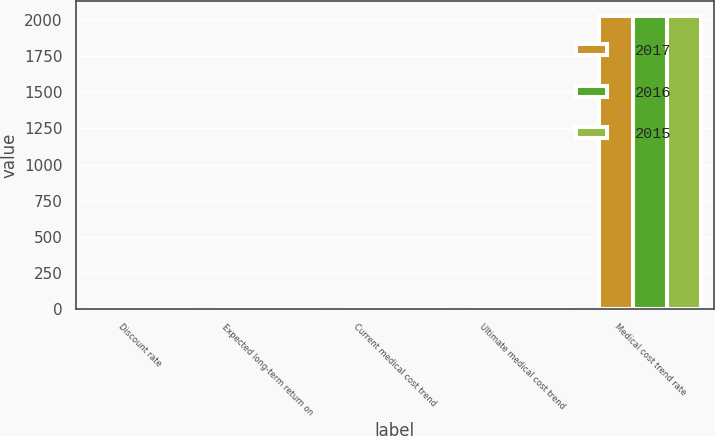Convert chart to OTSL. <chart><loc_0><loc_0><loc_500><loc_500><stacked_bar_chart><ecel><fcel>Discount rate<fcel>Expected long-term return on<fcel>Current medical cost trend<fcel>Ultimate medical cost trend<fcel>Medical cost trend rate<nl><fcel>2017<fcel>3.75<fcel>7.25<fcel>6<fcel>3.5<fcel>2029<nl><fcel>2016<fcel>4.2<fcel>7.5<fcel>7<fcel>3.5<fcel>2029<nl><fcel>2015<fcel>4<fcel>8<fcel>8<fcel>3.5<fcel>2028<nl></chart> 